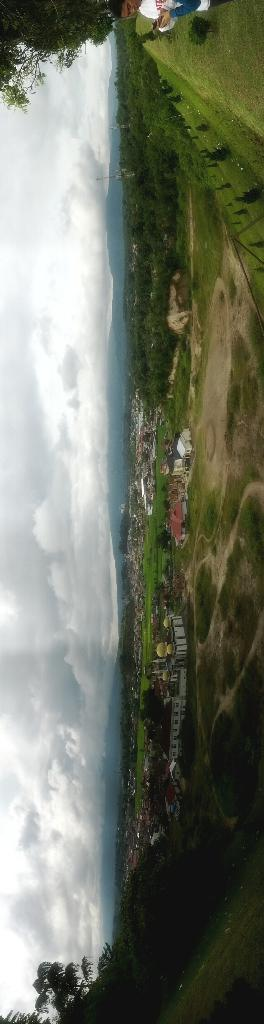What type of landscape is depicted in the image? The image features fields. What can be found within the fields? There are trees, plants, and grass in the fields. Are there any structures visible in the image? Yes, there are houses in the image. Can you describe the presence of people in the image? There is a person in the image. What type of whistle can be heard coming from the end of the minute in the image? There is no whistle or indication of time in the image, so it's not possible to determine what, if any, whistle might be heard. 